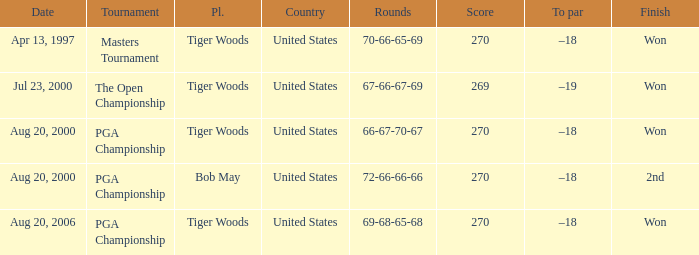What days were the rounds of 66-67-70-67 recorded? Aug 20, 2000. Parse the table in full. {'header': ['Date', 'Tournament', 'Pl.', 'Country', 'Rounds', 'Score', 'To par', 'Finish'], 'rows': [['Apr 13, 1997', 'Masters Tournament', 'Tiger Woods', 'United States', '70-66-65-69', '270', '–18', 'Won'], ['Jul 23, 2000', 'The Open Championship', 'Tiger Woods', 'United States', '67-66-67-69', '269', '–19', 'Won'], ['Aug 20, 2000', 'PGA Championship', 'Tiger Woods', 'United States', '66-67-70-67', '270', '–18', 'Won'], ['Aug 20, 2000', 'PGA Championship', 'Bob May', 'United States', '72-66-66-66', '270', '–18', '2nd'], ['Aug 20, 2006', 'PGA Championship', 'Tiger Woods', 'United States', '69-68-65-68', '270', '–18', 'Won']]} 